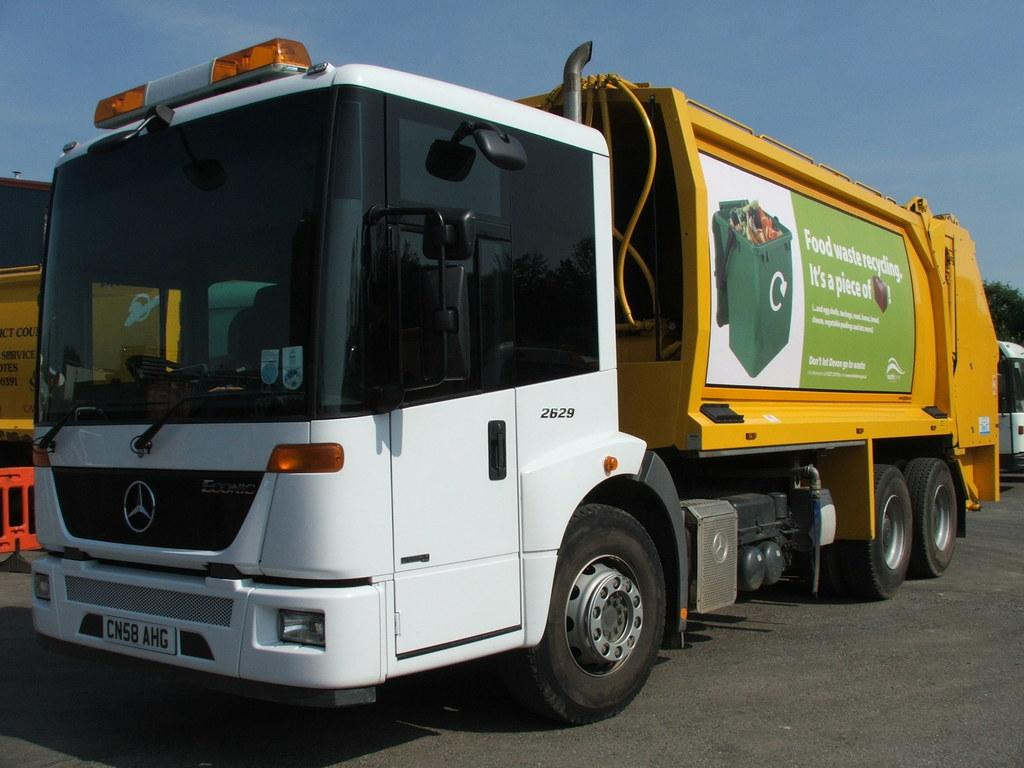<image>
Present a compact description of the photo's key features. food waste is written on the side of s truck 